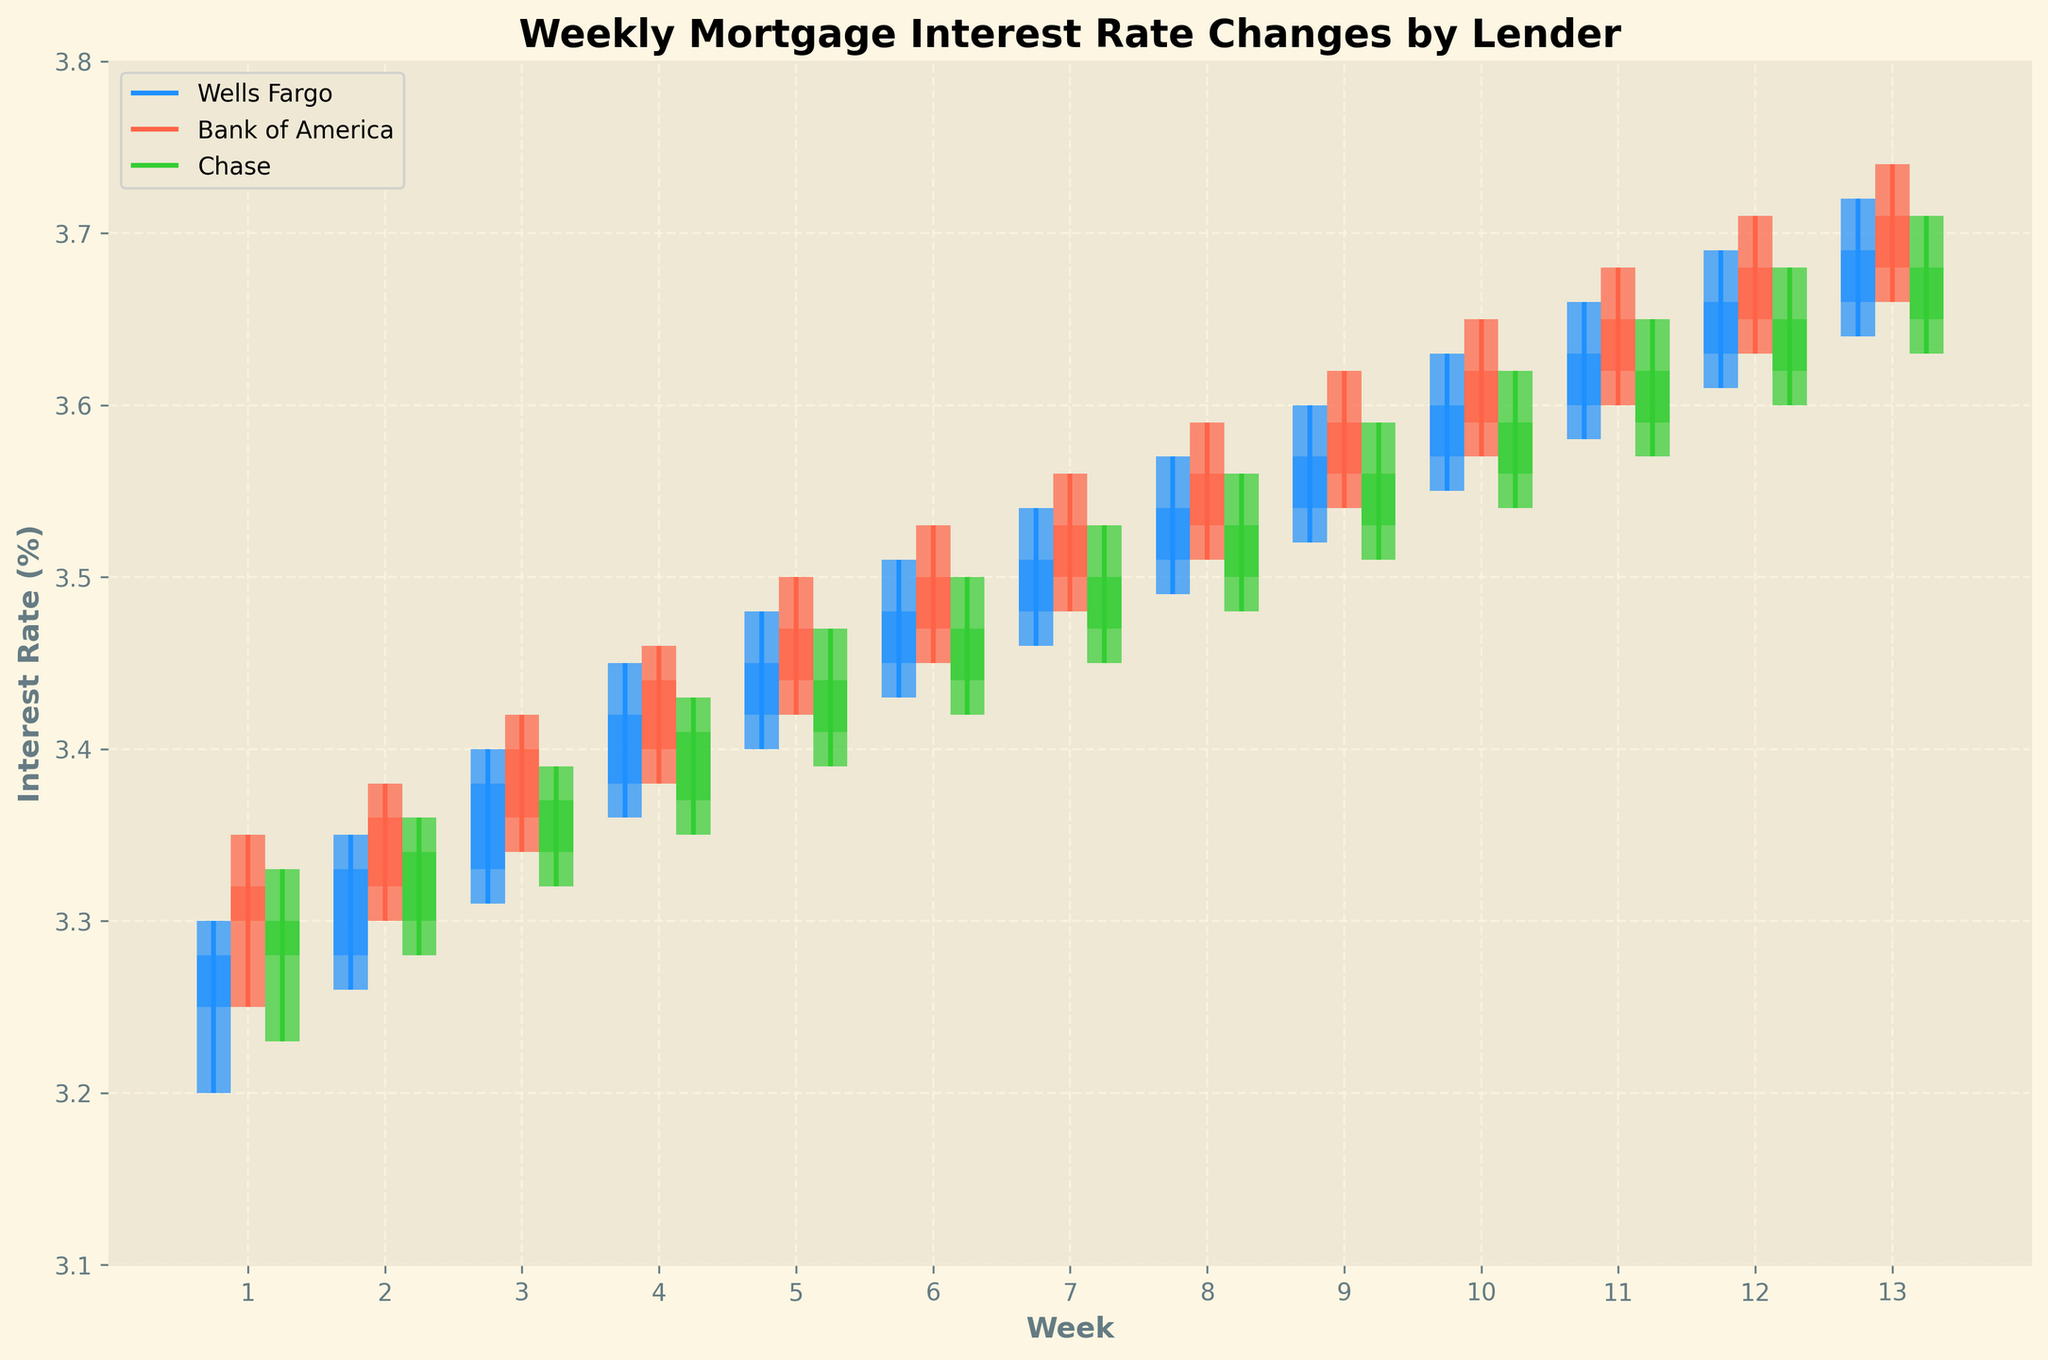What is the title of the figure? The title of the figure is displayed at the top center of the chart, and it summarizes the content and purpose of the chart.
Answer: Weekly Mortgage Interest Rate Changes by Lender How many lenders are compared in the figure? By counting the different labels in the legend or identifying the different colored bars and lines in the chart, we can see that there are three lenders being compared.
Answer: Three Which lender had the highest closing interest rate in week 3? To determine the highest closing interest rate for week 3, we need to compare the closing values of all three lenders for that particular week. Bank of America had a closing rate of 3.40%, Wells Fargo had 3.38%, and Chase had 3.37%.
Answer: Bank of America How did the weekly closing rate of Wells Fargo change from week 1 to week 13? We need to subtract the closing rate of week 1 (3.28%) from the closing rate of week 13 (3.69%). This calculates the change over the weeks. \(3.69 - 3.28 = 0.41%\)
Answer: Increased by 0.41% Which lender had the widest range of interest rates in week 5? We calculate the range (High - Low) for each lender in week 5. Wells Fargo: \(3.48 - 3.40 = 0.08\), Bank of America: \(3.50 - 3.42 = 0.08\), Chase: \(3.47 - 3.39 = 0.08\). All lenders have the same range.
Answer: All lenders have the same range On average, which lender had the highest opening rate over the quarter? We calculate the average opening rate for each lender over the 13 weeks by summing their opening rates and dividing by the number of weeks. Wells Fargo: \(\frac{3.25+3.28+3.33+3.38+3.42+3.45+3.48+3.51+3.54+3.57+3.60+3.63+3.66}{13} = 3.49\), Bank of America: \(\frac{3.30+3.32+3.36+3.40+3.44+3.47+3.50+3.53+3.56+3.59+3.62+3.65+3.68}{13} = 3.50\), Chase: \(\frac{3.28+3.30+3.34+3.37+3.41+3.44+3.47+3.50+3.53+3.56+3.59+3.62+3.65}{13} = 3.48\). Therefore, Bank of America had the highest average opening rate.
Answer: Bank of America Which lender showed the most consistent trend (smallest variation) in closing rates over the quarter? We calculate the standard deviation of the closing rates for each lender, as it measures the amount of variation or dispersion. By examining the data, Wells Fargo's closing rates: SD ≈ 0.14, Bank of America's closing rates: SD ≈ 0.14, and Chase's closing rates: SD ≈ 0.13. Chase has the smallest standard deviation.
Answer: Chase In week 10, which lender had the smallest difference between its high and low rates? We calculate the difference (High - Low) for each lender in week 10: Wells Fargo: \(3.63 - 3.55 = 0.08\), Bank of America: \(3.65 - 3.57 = 0.08\), Chase: \(3.62 - 3.54 = 0.08\). All lenders had the same difference.
Answer: All lenders What was the overall trend for Bank of America's closing rates from week 1 to week 13? We identify the pattern in the closing rates of Bank of America from the start to the end of the quarter, noticing that they generally increased from 3.32% in week 1 to 3.71% in week 13. This indicates a steady upward trend.
Answer: Upward trend 